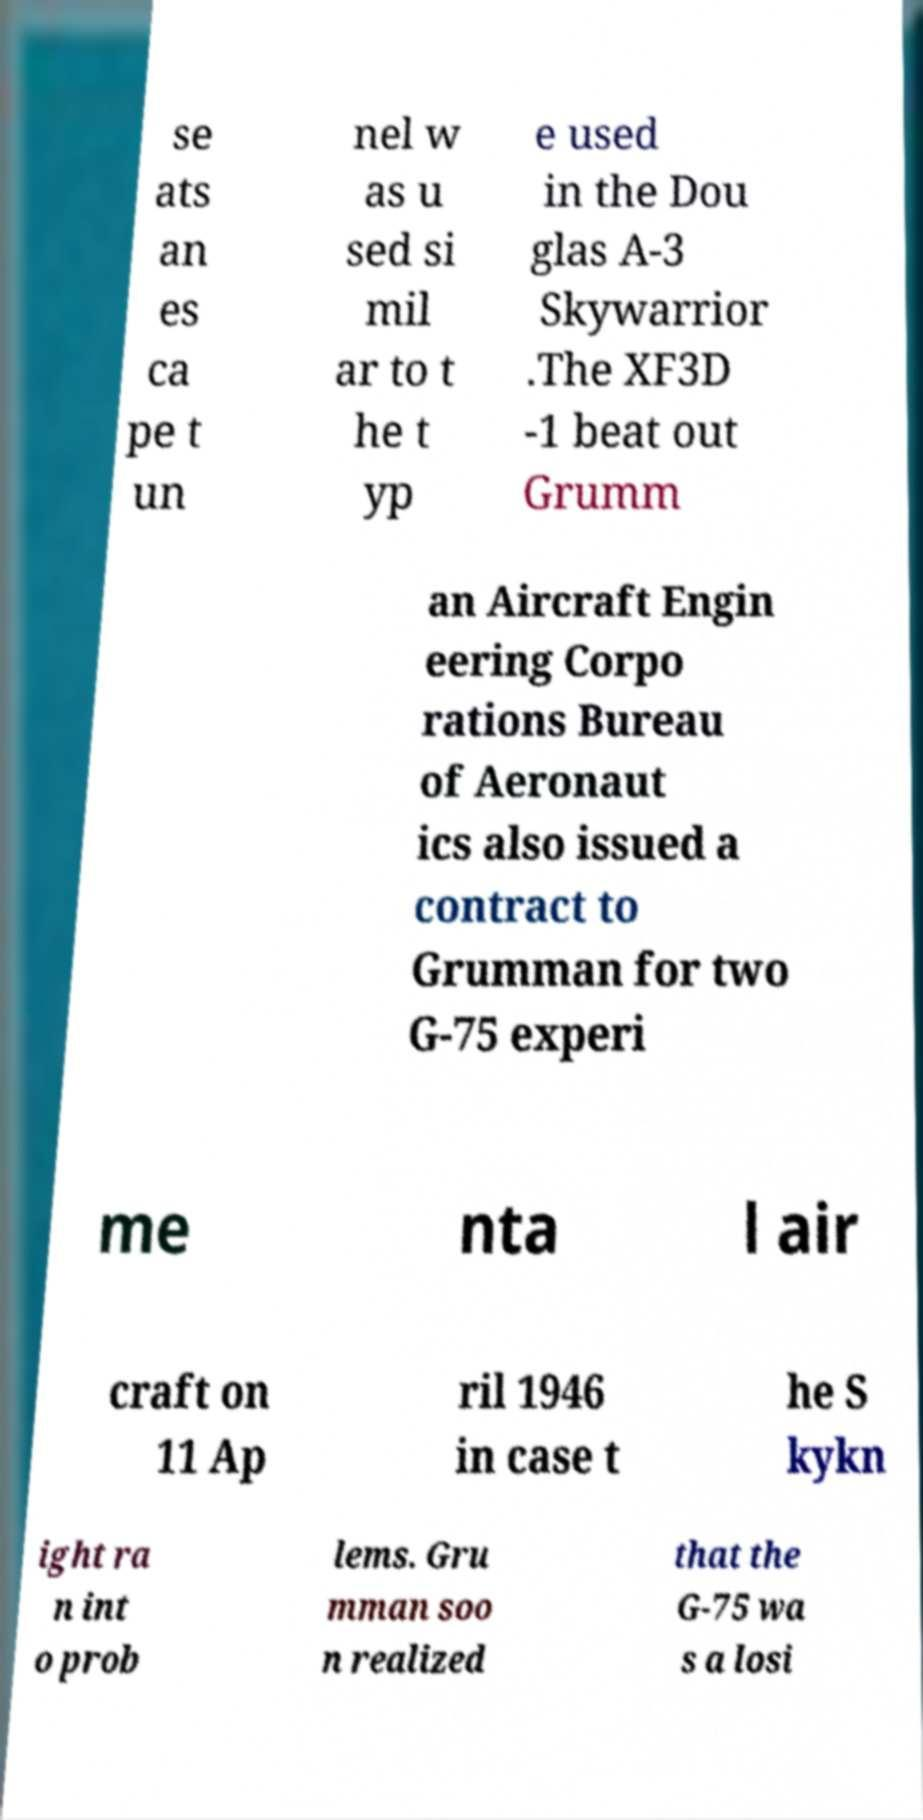There's text embedded in this image that I need extracted. Can you transcribe it verbatim? se ats an es ca pe t un nel w as u sed si mil ar to t he t yp e used in the Dou glas A-3 Skywarrior .The XF3D -1 beat out Grumm an Aircraft Engin eering Corpo rations Bureau of Aeronaut ics also issued a contract to Grumman for two G-75 experi me nta l air craft on 11 Ap ril 1946 in case t he S kykn ight ra n int o prob lems. Gru mman soo n realized that the G-75 wa s a losi 